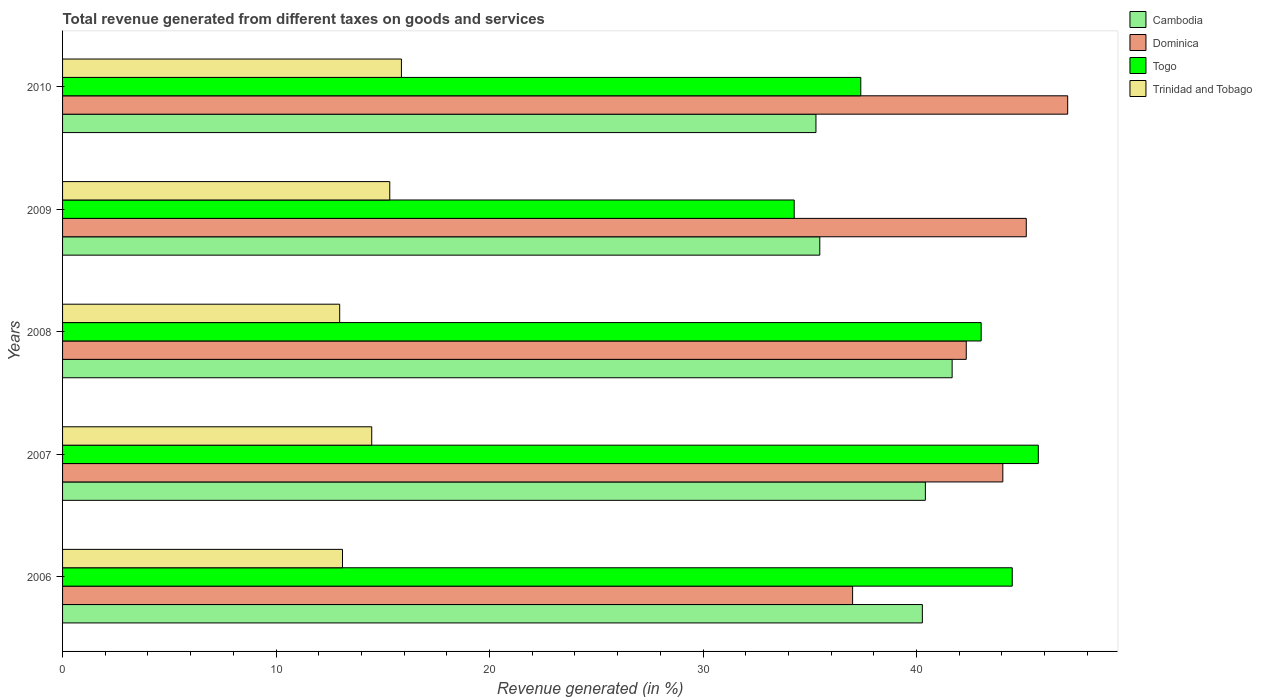How many different coloured bars are there?
Give a very brief answer. 4. Are the number of bars on each tick of the Y-axis equal?
Your answer should be compact. Yes. How many bars are there on the 3rd tick from the top?
Keep it short and to the point. 4. How many bars are there on the 4th tick from the bottom?
Offer a terse response. 4. In how many cases, is the number of bars for a given year not equal to the number of legend labels?
Give a very brief answer. 0. What is the total revenue generated in Trinidad and Tobago in 2010?
Give a very brief answer. 15.87. Across all years, what is the maximum total revenue generated in Dominica?
Your answer should be very brief. 47.08. Across all years, what is the minimum total revenue generated in Cambodia?
Your answer should be very brief. 35.29. In which year was the total revenue generated in Dominica minimum?
Provide a short and direct response. 2006. What is the total total revenue generated in Trinidad and Tobago in the graph?
Your answer should be compact. 71.78. What is the difference between the total revenue generated in Trinidad and Tobago in 2006 and that in 2007?
Give a very brief answer. -1.37. What is the difference between the total revenue generated in Dominica in 2010 and the total revenue generated in Cambodia in 2006?
Ensure brevity in your answer.  6.81. What is the average total revenue generated in Dominica per year?
Your answer should be compact. 43.12. In the year 2007, what is the difference between the total revenue generated in Trinidad and Tobago and total revenue generated in Dominica?
Give a very brief answer. -29.56. What is the ratio of the total revenue generated in Trinidad and Tobago in 2009 to that in 2010?
Give a very brief answer. 0.97. Is the total revenue generated in Cambodia in 2006 less than that in 2010?
Provide a succinct answer. No. What is the difference between the highest and the second highest total revenue generated in Dominica?
Offer a terse response. 1.94. What is the difference between the highest and the lowest total revenue generated in Dominica?
Offer a very short reply. 10.07. Is the sum of the total revenue generated in Cambodia in 2007 and 2009 greater than the maximum total revenue generated in Dominica across all years?
Offer a terse response. Yes. What does the 4th bar from the top in 2008 represents?
Ensure brevity in your answer.  Cambodia. What does the 2nd bar from the bottom in 2006 represents?
Provide a succinct answer. Dominica. Is it the case that in every year, the sum of the total revenue generated in Dominica and total revenue generated in Cambodia is greater than the total revenue generated in Togo?
Provide a short and direct response. Yes. How many bars are there?
Your answer should be compact. 20. How many years are there in the graph?
Offer a terse response. 5. What is the difference between two consecutive major ticks on the X-axis?
Your answer should be compact. 10. Does the graph contain any zero values?
Provide a short and direct response. No. How many legend labels are there?
Provide a short and direct response. 4. How are the legend labels stacked?
Offer a terse response. Vertical. What is the title of the graph?
Provide a short and direct response. Total revenue generated from different taxes on goods and services. Does "Myanmar" appear as one of the legend labels in the graph?
Your response must be concise. No. What is the label or title of the X-axis?
Make the answer very short. Revenue generated (in %). What is the label or title of the Y-axis?
Offer a very short reply. Years. What is the Revenue generated (in %) of Cambodia in 2006?
Make the answer very short. 40.28. What is the Revenue generated (in %) of Dominica in 2006?
Give a very brief answer. 37.01. What is the Revenue generated (in %) in Togo in 2006?
Keep it short and to the point. 44.49. What is the Revenue generated (in %) of Trinidad and Tobago in 2006?
Your answer should be very brief. 13.11. What is the Revenue generated (in %) in Cambodia in 2007?
Make the answer very short. 40.42. What is the Revenue generated (in %) of Dominica in 2007?
Provide a succinct answer. 44.04. What is the Revenue generated (in %) in Togo in 2007?
Give a very brief answer. 45.71. What is the Revenue generated (in %) of Trinidad and Tobago in 2007?
Your answer should be compact. 14.48. What is the Revenue generated (in %) in Cambodia in 2008?
Give a very brief answer. 41.67. What is the Revenue generated (in %) in Dominica in 2008?
Give a very brief answer. 42.33. What is the Revenue generated (in %) in Togo in 2008?
Offer a very short reply. 43.03. What is the Revenue generated (in %) of Trinidad and Tobago in 2008?
Your response must be concise. 12.98. What is the Revenue generated (in %) of Cambodia in 2009?
Your answer should be very brief. 35.47. What is the Revenue generated (in %) in Dominica in 2009?
Offer a terse response. 45.14. What is the Revenue generated (in %) of Togo in 2009?
Offer a very short reply. 34.27. What is the Revenue generated (in %) in Trinidad and Tobago in 2009?
Offer a very short reply. 15.33. What is the Revenue generated (in %) of Cambodia in 2010?
Your answer should be compact. 35.29. What is the Revenue generated (in %) in Dominica in 2010?
Your answer should be compact. 47.08. What is the Revenue generated (in %) in Togo in 2010?
Provide a succinct answer. 37.39. What is the Revenue generated (in %) of Trinidad and Tobago in 2010?
Give a very brief answer. 15.87. Across all years, what is the maximum Revenue generated (in %) in Cambodia?
Give a very brief answer. 41.67. Across all years, what is the maximum Revenue generated (in %) of Dominica?
Give a very brief answer. 47.08. Across all years, what is the maximum Revenue generated (in %) in Togo?
Give a very brief answer. 45.71. Across all years, what is the maximum Revenue generated (in %) in Trinidad and Tobago?
Ensure brevity in your answer.  15.87. Across all years, what is the minimum Revenue generated (in %) in Cambodia?
Your response must be concise. 35.29. Across all years, what is the minimum Revenue generated (in %) in Dominica?
Make the answer very short. 37.01. Across all years, what is the minimum Revenue generated (in %) in Togo?
Your response must be concise. 34.27. Across all years, what is the minimum Revenue generated (in %) of Trinidad and Tobago?
Provide a succinct answer. 12.98. What is the total Revenue generated (in %) in Cambodia in the graph?
Provide a short and direct response. 193.12. What is the total Revenue generated (in %) in Dominica in the graph?
Offer a very short reply. 215.61. What is the total Revenue generated (in %) of Togo in the graph?
Ensure brevity in your answer.  204.89. What is the total Revenue generated (in %) in Trinidad and Tobago in the graph?
Provide a short and direct response. 71.78. What is the difference between the Revenue generated (in %) of Cambodia in 2006 and that in 2007?
Offer a very short reply. -0.14. What is the difference between the Revenue generated (in %) of Dominica in 2006 and that in 2007?
Make the answer very short. -7.04. What is the difference between the Revenue generated (in %) of Togo in 2006 and that in 2007?
Provide a succinct answer. -1.22. What is the difference between the Revenue generated (in %) of Trinidad and Tobago in 2006 and that in 2007?
Offer a very short reply. -1.37. What is the difference between the Revenue generated (in %) in Cambodia in 2006 and that in 2008?
Give a very brief answer. -1.39. What is the difference between the Revenue generated (in %) of Dominica in 2006 and that in 2008?
Your response must be concise. -5.32. What is the difference between the Revenue generated (in %) of Togo in 2006 and that in 2008?
Offer a terse response. 1.46. What is the difference between the Revenue generated (in %) in Trinidad and Tobago in 2006 and that in 2008?
Make the answer very short. 0.13. What is the difference between the Revenue generated (in %) in Cambodia in 2006 and that in 2009?
Make the answer very short. 4.8. What is the difference between the Revenue generated (in %) of Dominica in 2006 and that in 2009?
Your answer should be compact. -8.14. What is the difference between the Revenue generated (in %) in Togo in 2006 and that in 2009?
Provide a short and direct response. 10.21. What is the difference between the Revenue generated (in %) in Trinidad and Tobago in 2006 and that in 2009?
Make the answer very short. -2.21. What is the difference between the Revenue generated (in %) in Cambodia in 2006 and that in 2010?
Provide a succinct answer. 4.99. What is the difference between the Revenue generated (in %) of Dominica in 2006 and that in 2010?
Offer a terse response. -10.07. What is the difference between the Revenue generated (in %) of Togo in 2006 and that in 2010?
Your answer should be compact. 7.1. What is the difference between the Revenue generated (in %) in Trinidad and Tobago in 2006 and that in 2010?
Provide a succinct answer. -2.76. What is the difference between the Revenue generated (in %) of Cambodia in 2007 and that in 2008?
Ensure brevity in your answer.  -1.25. What is the difference between the Revenue generated (in %) of Dominica in 2007 and that in 2008?
Your response must be concise. 1.71. What is the difference between the Revenue generated (in %) in Togo in 2007 and that in 2008?
Give a very brief answer. 2.68. What is the difference between the Revenue generated (in %) in Trinidad and Tobago in 2007 and that in 2008?
Ensure brevity in your answer.  1.5. What is the difference between the Revenue generated (in %) in Cambodia in 2007 and that in 2009?
Provide a short and direct response. 4.95. What is the difference between the Revenue generated (in %) of Dominica in 2007 and that in 2009?
Provide a succinct answer. -1.1. What is the difference between the Revenue generated (in %) of Togo in 2007 and that in 2009?
Your answer should be compact. 11.44. What is the difference between the Revenue generated (in %) of Trinidad and Tobago in 2007 and that in 2009?
Provide a succinct answer. -0.84. What is the difference between the Revenue generated (in %) in Cambodia in 2007 and that in 2010?
Make the answer very short. 5.13. What is the difference between the Revenue generated (in %) of Dominica in 2007 and that in 2010?
Make the answer very short. -3.04. What is the difference between the Revenue generated (in %) of Togo in 2007 and that in 2010?
Provide a short and direct response. 8.32. What is the difference between the Revenue generated (in %) in Trinidad and Tobago in 2007 and that in 2010?
Provide a succinct answer. -1.39. What is the difference between the Revenue generated (in %) in Cambodia in 2008 and that in 2009?
Your answer should be compact. 6.2. What is the difference between the Revenue generated (in %) of Dominica in 2008 and that in 2009?
Provide a succinct answer. -2.81. What is the difference between the Revenue generated (in %) of Togo in 2008 and that in 2009?
Offer a terse response. 8.76. What is the difference between the Revenue generated (in %) of Trinidad and Tobago in 2008 and that in 2009?
Your answer should be compact. -2.35. What is the difference between the Revenue generated (in %) in Cambodia in 2008 and that in 2010?
Provide a succinct answer. 6.38. What is the difference between the Revenue generated (in %) of Dominica in 2008 and that in 2010?
Give a very brief answer. -4.75. What is the difference between the Revenue generated (in %) in Togo in 2008 and that in 2010?
Ensure brevity in your answer.  5.64. What is the difference between the Revenue generated (in %) of Trinidad and Tobago in 2008 and that in 2010?
Offer a terse response. -2.89. What is the difference between the Revenue generated (in %) in Cambodia in 2009 and that in 2010?
Give a very brief answer. 0.18. What is the difference between the Revenue generated (in %) in Dominica in 2009 and that in 2010?
Provide a succinct answer. -1.94. What is the difference between the Revenue generated (in %) in Togo in 2009 and that in 2010?
Offer a very short reply. -3.12. What is the difference between the Revenue generated (in %) in Trinidad and Tobago in 2009 and that in 2010?
Provide a short and direct response. -0.55. What is the difference between the Revenue generated (in %) of Cambodia in 2006 and the Revenue generated (in %) of Dominica in 2007?
Provide a short and direct response. -3.77. What is the difference between the Revenue generated (in %) of Cambodia in 2006 and the Revenue generated (in %) of Togo in 2007?
Give a very brief answer. -5.43. What is the difference between the Revenue generated (in %) in Cambodia in 2006 and the Revenue generated (in %) in Trinidad and Tobago in 2007?
Your response must be concise. 25.79. What is the difference between the Revenue generated (in %) in Dominica in 2006 and the Revenue generated (in %) in Togo in 2007?
Give a very brief answer. -8.7. What is the difference between the Revenue generated (in %) of Dominica in 2006 and the Revenue generated (in %) of Trinidad and Tobago in 2007?
Ensure brevity in your answer.  22.53. What is the difference between the Revenue generated (in %) in Togo in 2006 and the Revenue generated (in %) in Trinidad and Tobago in 2007?
Offer a very short reply. 30. What is the difference between the Revenue generated (in %) of Cambodia in 2006 and the Revenue generated (in %) of Dominica in 2008?
Offer a terse response. -2.06. What is the difference between the Revenue generated (in %) of Cambodia in 2006 and the Revenue generated (in %) of Togo in 2008?
Your response must be concise. -2.75. What is the difference between the Revenue generated (in %) in Cambodia in 2006 and the Revenue generated (in %) in Trinidad and Tobago in 2008?
Provide a succinct answer. 27.29. What is the difference between the Revenue generated (in %) in Dominica in 2006 and the Revenue generated (in %) in Togo in 2008?
Keep it short and to the point. -6.02. What is the difference between the Revenue generated (in %) of Dominica in 2006 and the Revenue generated (in %) of Trinidad and Tobago in 2008?
Offer a terse response. 24.03. What is the difference between the Revenue generated (in %) of Togo in 2006 and the Revenue generated (in %) of Trinidad and Tobago in 2008?
Give a very brief answer. 31.5. What is the difference between the Revenue generated (in %) of Cambodia in 2006 and the Revenue generated (in %) of Dominica in 2009?
Give a very brief answer. -4.87. What is the difference between the Revenue generated (in %) in Cambodia in 2006 and the Revenue generated (in %) in Togo in 2009?
Your answer should be compact. 6. What is the difference between the Revenue generated (in %) of Cambodia in 2006 and the Revenue generated (in %) of Trinidad and Tobago in 2009?
Keep it short and to the point. 24.95. What is the difference between the Revenue generated (in %) of Dominica in 2006 and the Revenue generated (in %) of Togo in 2009?
Provide a succinct answer. 2.74. What is the difference between the Revenue generated (in %) of Dominica in 2006 and the Revenue generated (in %) of Trinidad and Tobago in 2009?
Provide a succinct answer. 21.68. What is the difference between the Revenue generated (in %) in Togo in 2006 and the Revenue generated (in %) in Trinidad and Tobago in 2009?
Your answer should be very brief. 29.16. What is the difference between the Revenue generated (in %) in Cambodia in 2006 and the Revenue generated (in %) in Dominica in 2010?
Offer a very short reply. -6.81. What is the difference between the Revenue generated (in %) of Cambodia in 2006 and the Revenue generated (in %) of Togo in 2010?
Offer a very short reply. 2.88. What is the difference between the Revenue generated (in %) in Cambodia in 2006 and the Revenue generated (in %) in Trinidad and Tobago in 2010?
Keep it short and to the point. 24.4. What is the difference between the Revenue generated (in %) of Dominica in 2006 and the Revenue generated (in %) of Togo in 2010?
Your answer should be compact. -0.38. What is the difference between the Revenue generated (in %) in Dominica in 2006 and the Revenue generated (in %) in Trinidad and Tobago in 2010?
Provide a succinct answer. 21.14. What is the difference between the Revenue generated (in %) in Togo in 2006 and the Revenue generated (in %) in Trinidad and Tobago in 2010?
Provide a succinct answer. 28.61. What is the difference between the Revenue generated (in %) in Cambodia in 2007 and the Revenue generated (in %) in Dominica in 2008?
Give a very brief answer. -1.92. What is the difference between the Revenue generated (in %) of Cambodia in 2007 and the Revenue generated (in %) of Togo in 2008?
Offer a terse response. -2.61. What is the difference between the Revenue generated (in %) of Cambodia in 2007 and the Revenue generated (in %) of Trinidad and Tobago in 2008?
Your response must be concise. 27.43. What is the difference between the Revenue generated (in %) of Dominica in 2007 and the Revenue generated (in %) of Togo in 2008?
Your response must be concise. 1.01. What is the difference between the Revenue generated (in %) in Dominica in 2007 and the Revenue generated (in %) in Trinidad and Tobago in 2008?
Keep it short and to the point. 31.06. What is the difference between the Revenue generated (in %) in Togo in 2007 and the Revenue generated (in %) in Trinidad and Tobago in 2008?
Your answer should be very brief. 32.73. What is the difference between the Revenue generated (in %) of Cambodia in 2007 and the Revenue generated (in %) of Dominica in 2009?
Provide a succinct answer. -4.73. What is the difference between the Revenue generated (in %) of Cambodia in 2007 and the Revenue generated (in %) of Togo in 2009?
Your answer should be very brief. 6.14. What is the difference between the Revenue generated (in %) of Cambodia in 2007 and the Revenue generated (in %) of Trinidad and Tobago in 2009?
Provide a short and direct response. 25.09. What is the difference between the Revenue generated (in %) of Dominica in 2007 and the Revenue generated (in %) of Togo in 2009?
Provide a short and direct response. 9.77. What is the difference between the Revenue generated (in %) of Dominica in 2007 and the Revenue generated (in %) of Trinidad and Tobago in 2009?
Make the answer very short. 28.72. What is the difference between the Revenue generated (in %) in Togo in 2007 and the Revenue generated (in %) in Trinidad and Tobago in 2009?
Make the answer very short. 30.38. What is the difference between the Revenue generated (in %) of Cambodia in 2007 and the Revenue generated (in %) of Dominica in 2010?
Your response must be concise. -6.67. What is the difference between the Revenue generated (in %) in Cambodia in 2007 and the Revenue generated (in %) in Togo in 2010?
Offer a very short reply. 3.03. What is the difference between the Revenue generated (in %) of Cambodia in 2007 and the Revenue generated (in %) of Trinidad and Tobago in 2010?
Provide a short and direct response. 24.54. What is the difference between the Revenue generated (in %) of Dominica in 2007 and the Revenue generated (in %) of Togo in 2010?
Provide a short and direct response. 6.65. What is the difference between the Revenue generated (in %) of Dominica in 2007 and the Revenue generated (in %) of Trinidad and Tobago in 2010?
Ensure brevity in your answer.  28.17. What is the difference between the Revenue generated (in %) in Togo in 2007 and the Revenue generated (in %) in Trinidad and Tobago in 2010?
Give a very brief answer. 29.83. What is the difference between the Revenue generated (in %) of Cambodia in 2008 and the Revenue generated (in %) of Dominica in 2009?
Your answer should be very brief. -3.47. What is the difference between the Revenue generated (in %) of Cambodia in 2008 and the Revenue generated (in %) of Togo in 2009?
Make the answer very short. 7.4. What is the difference between the Revenue generated (in %) of Cambodia in 2008 and the Revenue generated (in %) of Trinidad and Tobago in 2009?
Your response must be concise. 26.34. What is the difference between the Revenue generated (in %) in Dominica in 2008 and the Revenue generated (in %) in Togo in 2009?
Offer a very short reply. 8.06. What is the difference between the Revenue generated (in %) of Dominica in 2008 and the Revenue generated (in %) of Trinidad and Tobago in 2009?
Provide a short and direct response. 27. What is the difference between the Revenue generated (in %) of Togo in 2008 and the Revenue generated (in %) of Trinidad and Tobago in 2009?
Ensure brevity in your answer.  27.7. What is the difference between the Revenue generated (in %) in Cambodia in 2008 and the Revenue generated (in %) in Dominica in 2010?
Ensure brevity in your answer.  -5.41. What is the difference between the Revenue generated (in %) in Cambodia in 2008 and the Revenue generated (in %) in Togo in 2010?
Your answer should be compact. 4.28. What is the difference between the Revenue generated (in %) in Cambodia in 2008 and the Revenue generated (in %) in Trinidad and Tobago in 2010?
Keep it short and to the point. 25.8. What is the difference between the Revenue generated (in %) of Dominica in 2008 and the Revenue generated (in %) of Togo in 2010?
Your answer should be very brief. 4.94. What is the difference between the Revenue generated (in %) in Dominica in 2008 and the Revenue generated (in %) in Trinidad and Tobago in 2010?
Your answer should be compact. 26.46. What is the difference between the Revenue generated (in %) in Togo in 2008 and the Revenue generated (in %) in Trinidad and Tobago in 2010?
Keep it short and to the point. 27.16. What is the difference between the Revenue generated (in %) of Cambodia in 2009 and the Revenue generated (in %) of Dominica in 2010?
Your response must be concise. -11.61. What is the difference between the Revenue generated (in %) in Cambodia in 2009 and the Revenue generated (in %) in Togo in 2010?
Offer a terse response. -1.92. What is the difference between the Revenue generated (in %) of Cambodia in 2009 and the Revenue generated (in %) of Trinidad and Tobago in 2010?
Your answer should be very brief. 19.6. What is the difference between the Revenue generated (in %) of Dominica in 2009 and the Revenue generated (in %) of Togo in 2010?
Provide a short and direct response. 7.75. What is the difference between the Revenue generated (in %) of Dominica in 2009 and the Revenue generated (in %) of Trinidad and Tobago in 2010?
Offer a very short reply. 29.27. What is the difference between the Revenue generated (in %) of Togo in 2009 and the Revenue generated (in %) of Trinidad and Tobago in 2010?
Provide a short and direct response. 18.4. What is the average Revenue generated (in %) in Cambodia per year?
Offer a terse response. 38.62. What is the average Revenue generated (in %) in Dominica per year?
Keep it short and to the point. 43.12. What is the average Revenue generated (in %) in Togo per year?
Your response must be concise. 40.98. What is the average Revenue generated (in %) of Trinidad and Tobago per year?
Offer a terse response. 14.36. In the year 2006, what is the difference between the Revenue generated (in %) of Cambodia and Revenue generated (in %) of Dominica?
Give a very brief answer. 3.27. In the year 2006, what is the difference between the Revenue generated (in %) of Cambodia and Revenue generated (in %) of Togo?
Your answer should be compact. -4.21. In the year 2006, what is the difference between the Revenue generated (in %) in Cambodia and Revenue generated (in %) in Trinidad and Tobago?
Keep it short and to the point. 27.16. In the year 2006, what is the difference between the Revenue generated (in %) in Dominica and Revenue generated (in %) in Togo?
Offer a terse response. -7.48. In the year 2006, what is the difference between the Revenue generated (in %) of Dominica and Revenue generated (in %) of Trinidad and Tobago?
Make the answer very short. 23.89. In the year 2006, what is the difference between the Revenue generated (in %) of Togo and Revenue generated (in %) of Trinidad and Tobago?
Provide a succinct answer. 31.37. In the year 2007, what is the difference between the Revenue generated (in %) in Cambodia and Revenue generated (in %) in Dominica?
Your response must be concise. -3.63. In the year 2007, what is the difference between the Revenue generated (in %) of Cambodia and Revenue generated (in %) of Togo?
Provide a short and direct response. -5.29. In the year 2007, what is the difference between the Revenue generated (in %) in Cambodia and Revenue generated (in %) in Trinidad and Tobago?
Give a very brief answer. 25.93. In the year 2007, what is the difference between the Revenue generated (in %) of Dominica and Revenue generated (in %) of Togo?
Provide a succinct answer. -1.66. In the year 2007, what is the difference between the Revenue generated (in %) of Dominica and Revenue generated (in %) of Trinidad and Tobago?
Ensure brevity in your answer.  29.56. In the year 2007, what is the difference between the Revenue generated (in %) in Togo and Revenue generated (in %) in Trinidad and Tobago?
Keep it short and to the point. 31.23. In the year 2008, what is the difference between the Revenue generated (in %) in Cambodia and Revenue generated (in %) in Dominica?
Your answer should be very brief. -0.66. In the year 2008, what is the difference between the Revenue generated (in %) in Cambodia and Revenue generated (in %) in Togo?
Keep it short and to the point. -1.36. In the year 2008, what is the difference between the Revenue generated (in %) in Cambodia and Revenue generated (in %) in Trinidad and Tobago?
Provide a succinct answer. 28.69. In the year 2008, what is the difference between the Revenue generated (in %) of Dominica and Revenue generated (in %) of Togo?
Your response must be concise. -0.7. In the year 2008, what is the difference between the Revenue generated (in %) of Dominica and Revenue generated (in %) of Trinidad and Tobago?
Ensure brevity in your answer.  29.35. In the year 2008, what is the difference between the Revenue generated (in %) in Togo and Revenue generated (in %) in Trinidad and Tobago?
Your response must be concise. 30.05. In the year 2009, what is the difference between the Revenue generated (in %) in Cambodia and Revenue generated (in %) in Dominica?
Your answer should be compact. -9.67. In the year 2009, what is the difference between the Revenue generated (in %) in Cambodia and Revenue generated (in %) in Togo?
Give a very brief answer. 1.2. In the year 2009, what is the difference between the Revenue generated (in %) in Cambodia and Revenue generated (in %) in Trinidad and Tobago?
Your response must be concise. 20.14. In the year 2009, what is the difference between the Revenue generated (in %) of Dominica and Revenue generated (in %) of Togo?
Offer a terse response. 10.87. In the year 2009, what is the difference between the Revenue generated (in %) of Dominica and Revenue generated (in %) of Trinidad and Tobago?
Offer a terse response. 29.82. In the year 2009, what is the difference between the Revenue generated (in %) of Togo and Revenue generated (in %) of Trinidad and Tobago?
Keep it short and to the point. 18.95. In the year 2010, what is the difference between the Revenue generated (in %) of Cambodia and Revenue generated (in %) of Dominica?
Provide a succinct answer. -11.79. In the year 2010, what is the difference between the Revenue generated (in %) of Cambodia and Revenue generated (in %) of Togo?
Keep it short and to the point. -2.1. In the year 2010, what is the difference between the Revenue generated (in %) in Cambodia and Revenue generated (in %) in Trinidad and Tobago?
Provide a succinct answer. 19.42. In the year 2010, what is the difference between the Revenue generated (in %) in Dominica and Revenue generated (in %) in Togo?
Make the answer very short. 9.69. In the year 2010, what is the difference between the Revenue generated (in %) in Dominica and Revenue generated (in %) in Trinidad and Tobago?
Offer a terse response. 31.21. In the year 2010, what is the difference between the Revenue generated (in %) in Togo and Revenue generated (in %) in Trinidad and Tobago?
Provide a short and direct response. 21.52. What is the ratio of the Revenue generated (in %) of Dominica in 2006 to that in 2007?
Provide a short and direct response. 0.84. What is the ratio of the Revenue generated (in %) of Togo in 2006 to that in 2007?
Your answer should be very brief. 0.97. What is the ratio of the Revenue generated (in %) in Trinidad and Tobago in 2006 to that in 2007?
Keep it short and to the point. 0.91. What is the ratio of the Revenue generated (in %) of Cambodia in 2006 to that in 2008?
Provide a succinct answer. 0.97. What is the ratio of the Revenue generated (in %) in Dominica in 2006 to that in 2008?
Ensure brevity in your answer.  0.87. What is the ratio of the Revenue generated (in %) in Togo in 2006 to that in 2008?
Give a very brief answer. 1.03. What is the ratio of the Revenue generated (in %) of Trinidad and Tobago in 2006 to that in 2008?
Make the answer very short. 1.01. What is the ratio of the Revenue generated (in %) of Cambodia in 2006 to that in 2009?
Your answer should be compact. 1.14. What is the ratio of the Revenue generated (in %) of Dominica in 2006 to that in 2009?
Give a very brief answer. 0.82. What is the ratio of the Revenue generated (in %) in Togo in 2006 to that in 2009?
Your answer should be very brief. 1.3. What is the ratio of the Revenue generated (in %) of Trinidad and Tobago in 2006 to that in 2009?
Keep it short and to the point. 0.86. What is the ratio of the Revenue generated (in %) in Cambodia in 2006 to that in 2010?
Provide a short and direct response. 1.14. What is the ratio of the Revenue generated (in %) of Dominica in 2006 to that in 2010?
Give a very brief answer. 0.79. What is the ratio of the Revenue generated (in %) of Togo in 2006 to that in 2010?
Make the answer very short. 1.19. What is the ratio of the Revenue generated (in %) of Trinidad and Tobago in 2006 to that in 2010?
Make the answer very short. 0.83. What is the ratio of the Revenue generated (in %) in Cambodia in 2007 to that in 2008?
Provide a succinct answer. 0.97. What is the ratio of the Revenue generated (in %) of Dominica in 2007 to that in 2008?
Offer a very short reply. 1.04. What is the ratio of the Revenue generated (in %) in Togo in 2007 to that in 2008?
Give a very brief answer. 1.06. What is the ratio of the Revenue generated (in %) of Trinidad and Tobago in 2007 to that in 2008?
Provide a succinct answer. 1.12. What is the ratio of the Revenue generated (in %) of Cambodia in 2007 to that in 2009?
Provide a short and direct response. 1.14. What is the ratio of the Revenue generated (in %) of Dominica in 2007 to that in 2009?
Give a very brief answer. 0.98. What is the ratio of the Revenue generated (in %) in Togo in 2007 to that in 2009?
Provide a short and direct response. 1.33. What is the ratio of the Revenue generated (in %) of Trinidad and Tobago in 2007 to that in 2009?
Offer a very short reply. 0.94. What is the ratio of the Revenue generated (in %) in Cambodia in 2007 to that in 2010?
Your answer should be compact. 1.15. What is the ratio of the Revenue generated (in %) in Dominica in 2007 to that in 2010?
Provide a succinct answer. 0.94. What is the ratio of the Revenue generated (in %) of Togo in 2007 to that in 2010?
Provide a short and direct response. 1.22. What is the ratio of the Revenue generated (in %) of Trinidad and Tobago in 2007 to that in 2010?
Keep it short and to the point. 0.91. What is the ratio of the Revenue generated (in %) in Cambodia in 2008 to that in 2009?
Offer a very short reply. 1.17. What is the ratio of the Revenue generated (in %) of Dominica in 2008 to that in 2009?
Your response must be concise. 0.94. What is the ratio of the Revenue generated (in %) of Togo in 2008 to that in 2009?
Give a very brief answer. 1.26. What is the ratio of the Revenue generated (in %) in Trinidad and Tobago in 2008 to that in 2009?
Your response must be concise. 0.85. What is the ratio of the Revenue generated (in %) of Cambodia in 2008 to that in 2010?
Offer a terse response. 1.18. What is the ratio of the Revenue generated (in %) of Dominica in 2008 to that in 2010?
Your response must be concise. 0.9. What is the ratio of the Revenue generated (in %) in Togo in 2008 to that in 2010?
Ensure brevity in your answer.  1.15. What is the ratio of the Revenue generated (in %) in Trinidad and Tobago in 2008 to that in 2010?
Give a very brief answer. 0.82. What is the ratio of the Revenue generated (in %) in Dominica in 2009 to that in 2010?
Make the answer very short. 0.96. What is the ratio of the Revenue generated (in %) in Togo in 2009 to that in 2010?
Your response must be concise. 0.92. What is the ratio of the Revenue generated (in %) in Trinidad and Tobago in 2009 to that in 2010?
Provide a succinct answer. 0.97. What is the difference between the highest and the second highest Revenue generated (in %) in Cambodia?
Your response must be concise. 1.25. What is the difference between the highest and the second highest Revenue generated (in %) in Dominica?
Offer a terse response. 1.94. What is the difference between the highest and the second highest Revenue generated (in %) in Togo?
Your answer should be compact. 1.22. What is the difference between the highest and the second highest Revenue generated (in %) of Trinidad and Tobago?
Make the answer very short. 0.55. What is the difference between the highest and the lowest Revenue generated (in %) in Cambodia?
Provide a succinct answer. 6.38. What is the difference between the highest and the lowest Revenue generated (in %) in Dominica?
Offer a very short reply. 10.07. What is the difference between the highest and the lowest Revenue generated (in %) in Togo?
Offer a terse response. 11.44. What is the difference between the highest and the lowest Revenue generated (in %) in Trinidad and Tobago?
Give a very brief answer. 2.89. 